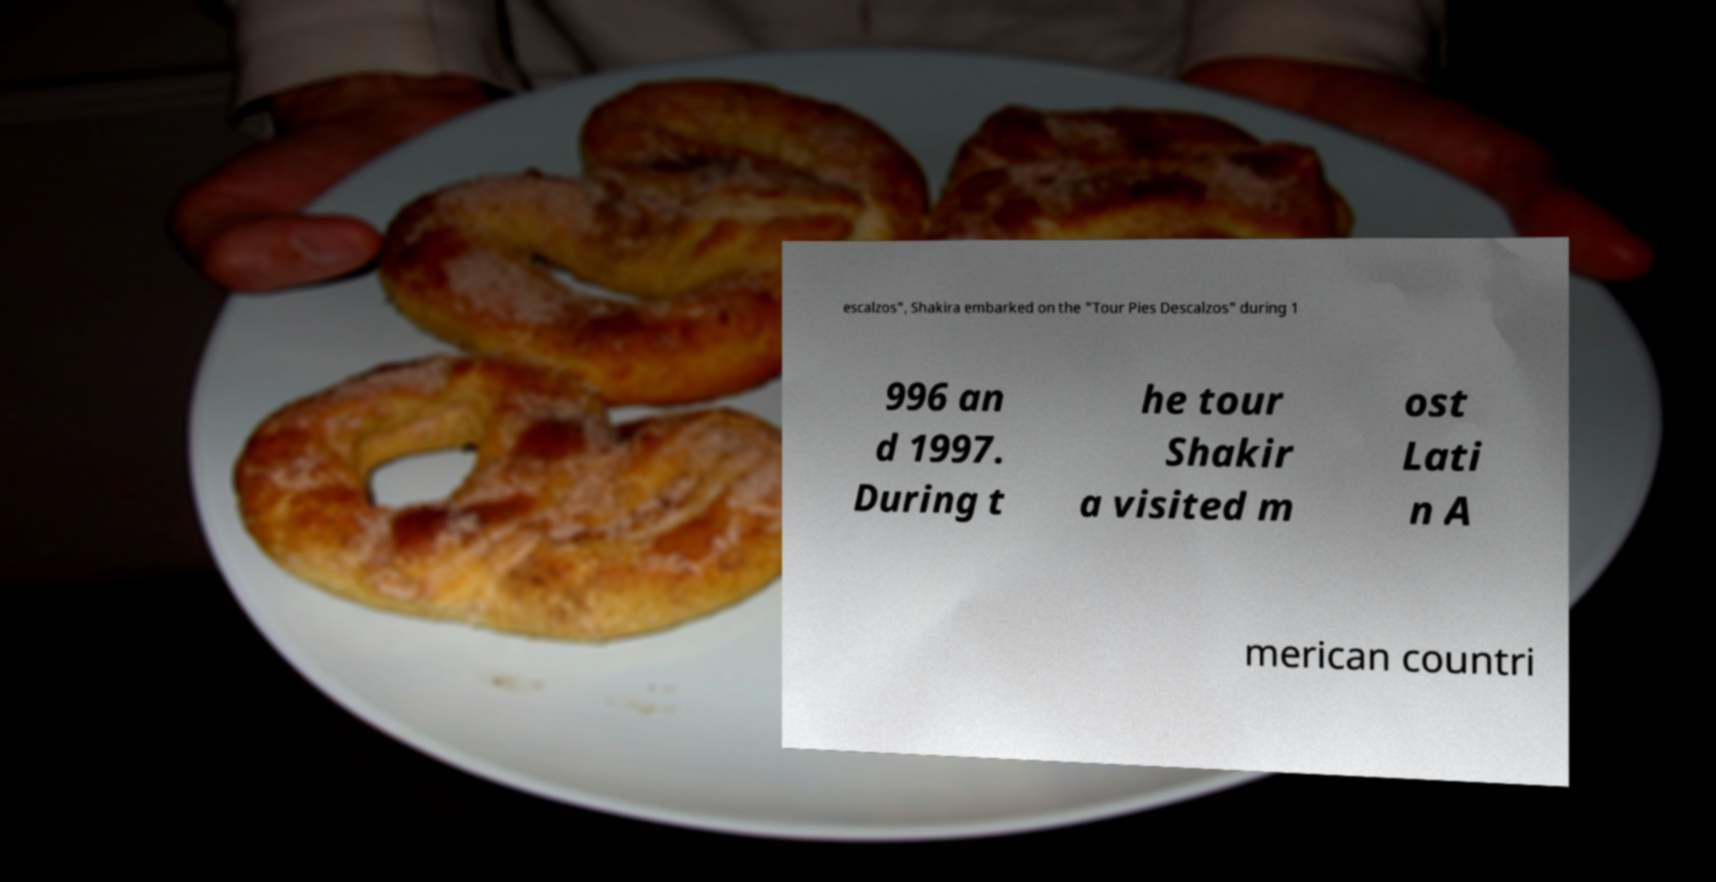Could you extract and type out the text from this image? escalzos", Shakira embarked on the "Tour Pies Descalzos" during 1 996 an d 1997. During t he tour Shakir a visited m ost Lati n A merican countri 